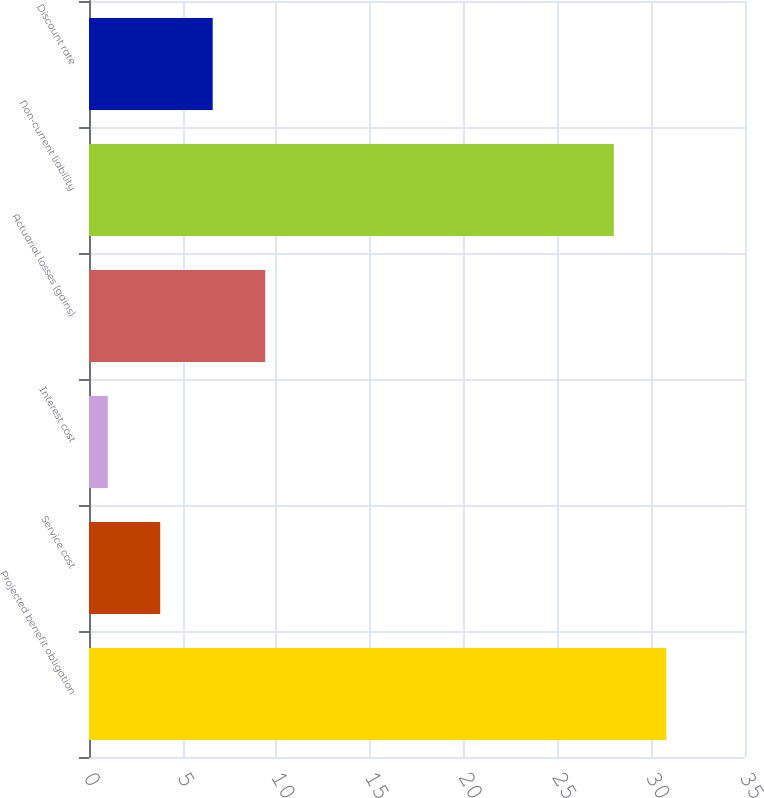Convert chart. <chart><loc_0><loc_0><loc_500><loc_500><bar_chart><fcel>Projected benefit obligation<fcel>Service cost<fcel>Interest cost<fcel>Actuarial losses (gains)<fcel>Non-current liability<fcel>Discount rate<nl><fcel>30.8<fcel>3.8<fcel>1<fcel>9.4<fcel>28<fcel>6.6<nl></chart> 